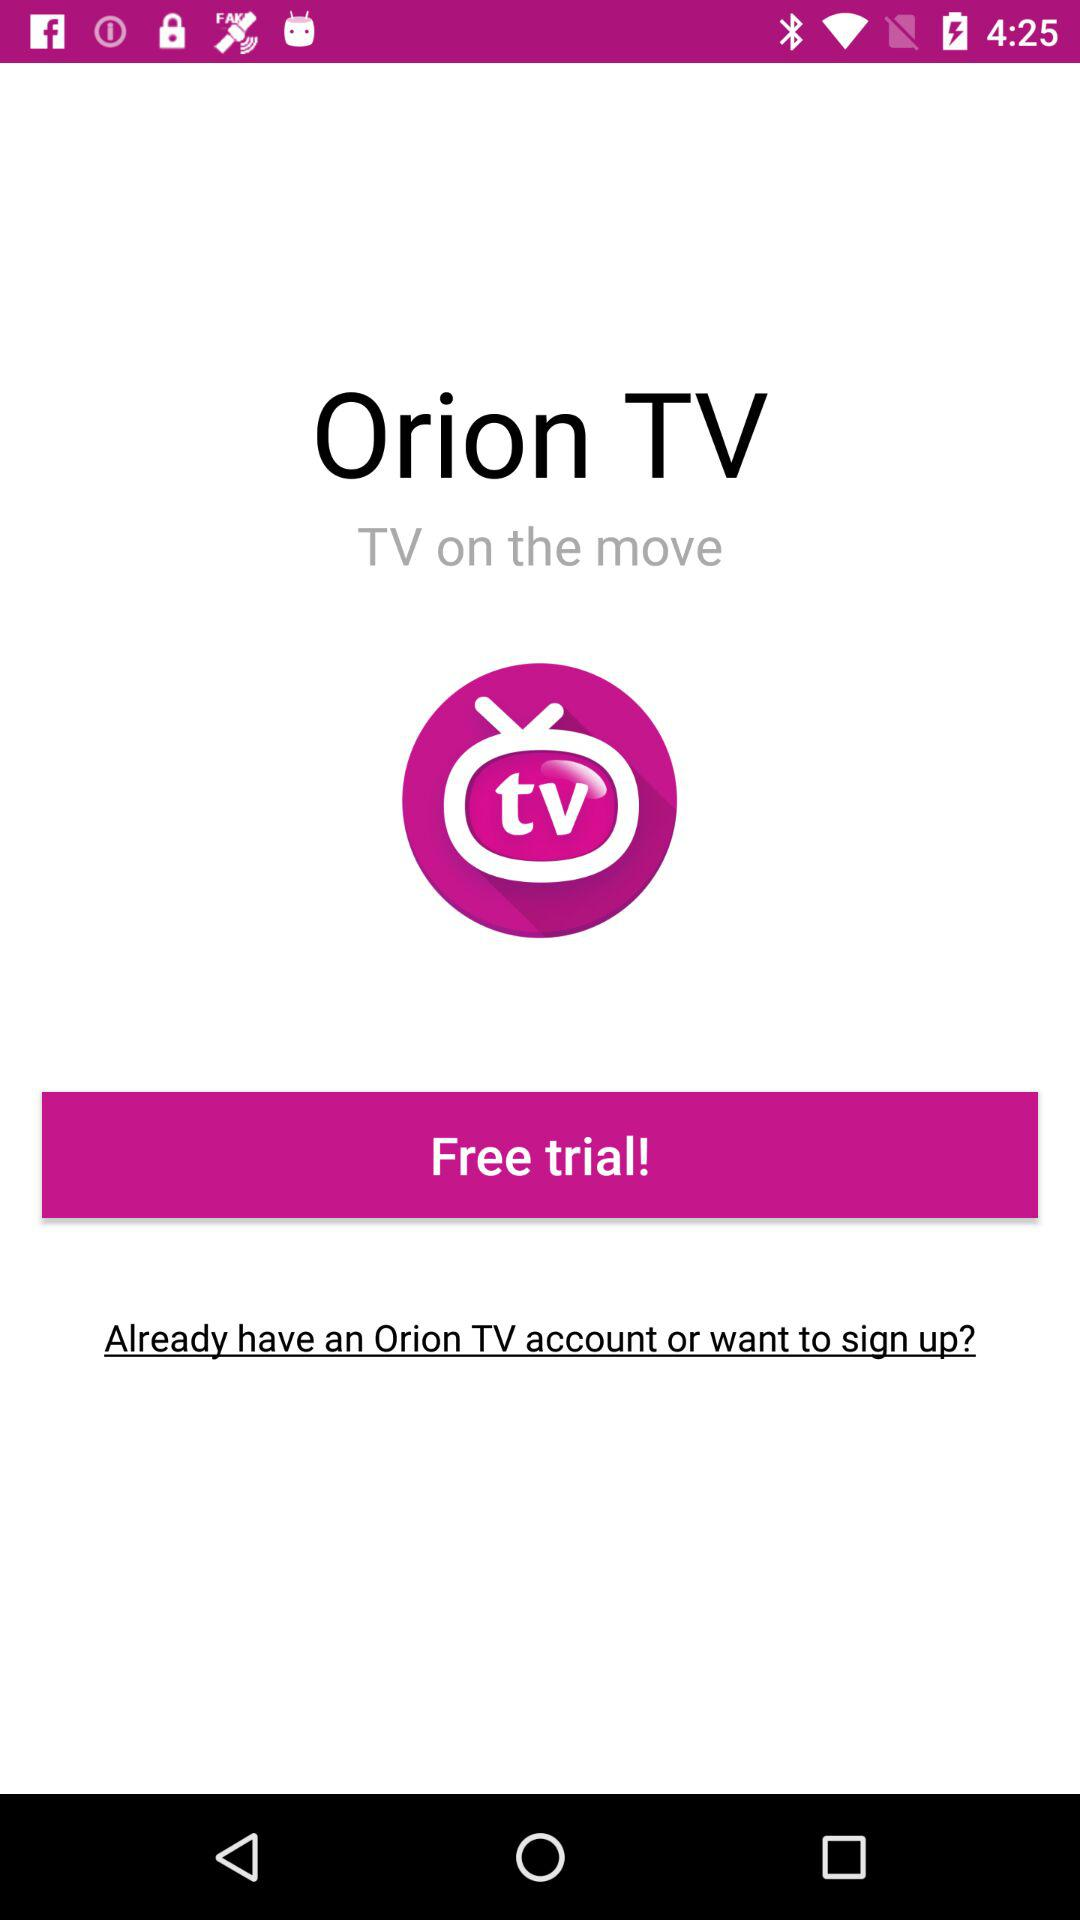What is the application name? The application name is "Orion TV". 